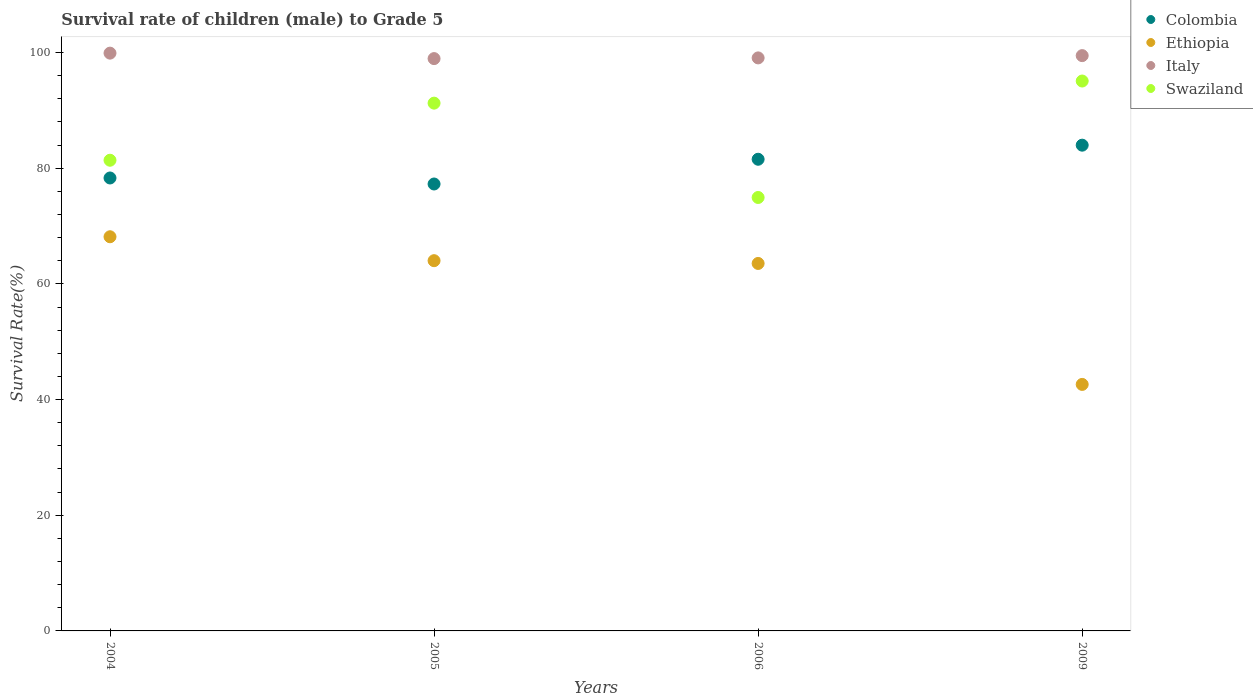What is the survival rate of male children to grade 5 in Swaziland in 2006?
Provide a short and direct response. 74.95. Across all years, what is the maximum survival rate of male children to grade 5 in Italy?
Offer a very short reply. 99.91. Across all years, what is the minimum survival rate of male children to grade 5 in Colombia?
Your response must be concise. 77.28. What is the total survival rate of male children to grade 5 in Italy in the graph?
Give a very brief answer. 397.43. What is the difference between the survival rate of male children to grade 5 in Ethiopia in 2004 and that in 2005?
Offer a very short reply. 4.14. What is the difference between the survival rate of male children to grade 5 in Swaziland in 2006 and the survival rate of male children to grade 5 in Italy in 2009?
Make the answer very short. -24.53. What is the average survival rate of male children to grade 5 in Ethiopia per year?
Your response must be concise. 59.59. In the year 2005, what is the difference between the survival rate of male children to grade 5 in Colombia and survival rate of male children to grade 5 in Swaziland?
Your answer should be compact. -13.98. What is the ratio of the survival rate of male children to grade 5 in Swaziland in 2004 to that in 2009?
Keep it short and to the point. 0.86. What is the difference between the highest and the second highest survival rate of male children to grade 5 in Swaziland?
Provide a succinct answer. 3.82. What is the difference between the highest and the lowest survival rate of male children to grade 5 in Colombia?
Provide a succinct answer. 6.71. Is the sum of the survival rate of male children to grade 5 in Swaziland in 2004 and 2005 greater than the maximum survival rate of male children to grade 5 in Colombia across all years?
Offer a terse response. Yes. How many dotlines are there?
Your answer should be very brief. 4. How many years are there in the graph?
Your response must be concise. 4. What is the difference between two consecutive major ticks on the Y-axis?
Your answer should be very brief. 20. Are the values on the major ticks of Y-axis written in scientific E-notation?
Provide a succinct answer. No. Does the graph contain any zero values?
Your answer should be compact. No. How many legend labels are there?
Offer a terse response. 4. What is the title of the graph?
Ensure brevity in your answer.  Survival rate of children (male) to Grade 5. What is the label or title of the Y-axis?
Offer a very short reply. Survival Rate(%). What is the Survival Rate(%) of Colombia in 2004?
Keep it short and to the point. 78.32. What is the Survival Rate(%) in Ethiopia in 2004?
Your answer should be compact. 68.16. What is the Survival Rate(%) in Italy in 2004?
Keep it short and to the point. 99.91. What is the Survival Rate(%) of Swaziland in 2004?
Your answer should be very brief. 81.39. What is the Survival Rate(%) of Colombia in 2005?
Give a very brief answer. 77.28. What is the Survival Rate(%) in Ethiopia in 2005?
Ensure brevity in your answer.  64.02. What is the Survival Rate(%) in Italy in 2005?
Offer a very short reply. 98.96. What is the Survival Rate(%) of Swaziland in 2005?
Make the answer very short. 91.26. What is the Survival Rate(%) of Colombia in 2006?
Provide a succinct answer. 81.56. What is the Survival Rate(%) in Ethiopia in 2006?
Provide a short and direct response. 63.54. What is the Survival Rate(%) in Italy in 2006?
Ensure brevity in your answer.  99.08. What is the Survival Rate(%) of Swaziland in 2006?
Keep it short and to the point. 74.95. What is the Survival Rate(%) in Colombia in 2009?
Your answer should be very brief. 83.99. What is the Survival Rate(%) in Ethiopia in 2009?
Your answer should be very brief. 42.62. What is the Survival Rate(%) of Italy in 2009?
Provide a short and direct response. 99.48. What is the Survival Rate(%) of Swaziland in 2009?
Provide a succinct answer. 95.08. Across all years, what is the maximum Survival Rate(%) in Colombia?
Provide a short and direct response. 83.99. Across all years, what is the maximum Survival Rate(%) of Ethiopia?
Provide a short and direct response. 68.16. Across all years, what is the maximum Survival Rate(%) of Italy?
Ensure brevity in your answer.  99.91. Across all years, what is the maximum Survival Rate(%) of Swaziland?
Offer a very short reply. 95.08. Across all years, what is the minimum Survival Rate(%) of Colombia?
Give a very brief answer. 77.28. Across all years, what is the minimum Survival Rate(%) of Ethiopia?
Offer a very short reply. 42.62. Across all years, what is the minimum Survival Rate(%) of Italy?
Your answer should be compact. 98.96. Across all years, what is the minimum Survival Rate(%) in Swaziland?
Your answer should be compact. 74.95. What is the total Survival Rate(%) of Colombia in the graph?
Offer a terse response. 321.15. What is the total Survival Rate(%) of Ethiopia in the graph?
Offer a terse response. 238.34. What is the total Survival Rate(%) of Italy in the graph?
Give a very brief answer. 397.43. What is the total Survival Rate(%) of Swaziland in the graph?
Ensure brevity in your answer.  342.68. What is the difference between the Survival Rate(%) in Colombia in 2004 and that in 2005?
Provide a short and direct response. 1.04. What is the difference between the Survival Rate(%) of Ethiopia in 2004 and that in 2005?
Offer a terse response. 4.14. What is the difference between the Survival Rate(%) of Italy in 2004 and that in 2005?
Your response must be concise. 0.94. What is the difference between the Survival Rate(%) of Swaziland in 2004 and that in 2005?
Provide a short and direct response. -9.87. What is the difference between the Survival Rate(%) in Colombia in 2004 and that in 2006?
Provide a succinct answer. -3.24. What is the difference between the Survival Rate(%) of Ethiopia in 2004 and that in 2006?
Provide a short and direct response. 4.62. What is the difference between the Survival Rate(%) in Italy in 2004 and that in 2006?
Your answer should be compact. 0.82. What is the difference between the Survival Rate(%) in Swaziland in 2004 and that in 2006?
Ensure brevity in your answer.  6.44. What is the difference between the Survival Rate(%) in Colombia in 2004 and that in 2009?
Provide a short and direct response. -5.67. What is the difference between the Survival Rate(%) in Ethiopia in 2004 and that in 2009?
Offer a terse response. 25.53. What is the difference between the Survival Rate(%) of Italy in 2004 and that in 2009?
Give a very brief answer. 0.43. What is the difference between the Survival Rate(%) of Swaziland in 2004 and that in 2009?
Provide a short and direct response. -13.7. What is the difference between the Survival Rate(%) of Colombia in 2005 and that in 2006?
Your answer should be compact. -4.28. What is the difference between the Survival Rate(%) in Ethiopia in 2005 and that in 2006?
Provide a short and direct response. 0.48. What is the difference between the Survival Rate(%) of Italy in 2005 and that in 2006?
Your response must be concise. -0.12. What is the difference between the Survival Rate(%) of Swaziland in 2005 and that in 2006?
Your response must be concise. 16.31. What is the difference between the Survival Rate(%) in Colombia in 2005 and that in 2009?
Ensure brevity in your answer.  -6.71. What is the difference between the Survival Rate(%) in Ethiopia in 2005 and that in 2009?
Ensure brevity in your answer.  21.4. What is the difference between the Survival Rate(%) of Italy in 2005 and that in 2009?
Your answer should be very brief. -0.51. What is the difference between the Survival Rate(%) in Swaziland in 2005 and that in 2009?
Your answer should be compact. -3.82. What is the difference between the Survival Rate(%) in Colombia in 2006 and that in 2009?
Your answer should be compact. -2.44. What is the difference between the Survival Rate(%) of Ethiopia in 2006 and that in 2009?
Make the answer very short. 20.92. What is the difference between the Survival Rate(%) in Italy in 2006 and that in 2009?
Give a very brief answer. -0.39. What is the difference between the Survival Rate(%) in Swaziland in 2006 and that in 2009?
Offer a very short reply. -20.14. What is the difference between the Survival Rate(%) of Colombia in 2004 and the Survival Rate(%) of Ethiopia in 2005?
Your response must be concise. 14.3. What is the difference between the Survival Rate(%) in Colombia in 2004 and the Survival Rate(%) in Italy in 2005?
Offer a very short reply. -20.64. What is the difference between the Survival Rate(%) of Colombia in 2004 and the Survival Rate(%) of Swaziland in 2005?
Make the answer very short. -12.94. What is the difference between the Survival Rate(%) in Ethiopia in 2004 and the Survival Rate(%) in Italy in 2005?
Offer a terse response. -30.81. What is the difference between the Survival Rate(%) in Ethiopia in 2004 and the Survival Rate(%) in Swaziland in 2005?
Offer a very short reply. -23.1. What is the difference between the Survival Rate(%) in Italy in 2004 and the Survival Rate(%) in Swaziland in 2005?
Your answer should be compact. 8.65. What is the difference between the Survival Rate(%) of Colombia in 2004 and the Survival Rate(%) of Ethiopia in 2006?
Make the answer very short. 14.78. What is the difference between the Survival Rate(%) of Colombia in 2004 and the Survival Rate(%) of Italy in 2006?
Offer a very short reply. -20.76. What is the difference between the Survival Rate(%) in Colombia in 2004 and the Survival Rate(%) in Swaziland in 2006?
Make the answer very short. 3.37. What is the difference between the Survival Rate(%) in Ethiopia in 2004 and the Survival Rate(%) in Italy in 2006?
Offer a very short reply. -30.93. What is the difference between the Survival Rate(%) of Ethiopia in 2004 and the Survival Rate(%) of Swaziland in 2006?
Make the answer very short. -6.79. What is the difference between the Survival Rate(%) of Italy in 2004 and the Survival Rate(%) of Swaziland in 2006?
Your response must be concise. 24.96. What is the difference between the Survival Rate(%) of Colombia in 2004 and the Survival Rate(%) of Ethiopia in 2009?
Your response must be concise. 35.7. What is the difference between the Survival Rate(%) of Colombia in 2004 and the Survival Rate(%) of Italy in 2009?
Ensure brevity in your answer.  -21.16. What is the difference between the Survival Rate(%) of Colombia in 2004 and the Survival Rate(%) of Swaziland in 2009?
Provide a short and direct response. -16.77. What is the difference between the Survival Rate(%) of Ethiopia in 2004 and the Survival Rate(%) of Italy in 2009?
Offer a very short reply. -31.32. What is the difference between the Survival Rate(%) of Ethiopia in 2004 and the Survival Rate(%) of Swaziland in 2009?
Provide a succinct answer. -26.93. What is the difference between the Survival Rate(%) of Italy in 2004 and the Survival Rate(%) of Swaziland in 2009?
Provide a short and direct response. 4.82. What is the difference between the Survival Rate(%) of Colombia in 2005 and the Survival Rate(%) of Ethiopia in 2006?
Provide a short and direct response. 13.74. What is the difference between the Survival Rate(%) of Colombia in 2005 and the Survival Rate(%) of Italy in 2006?
Make the answer very short. -21.8. What is the difference between the Survival Rate(%) in Colombia in 2005 and the Survival Rate(%) in Swaziland in 2006?
Offer a very short reply. 2.33. What is the difference between the Survival Rate(%) of Ethiopia in 2005 and the Survival Rate(%) of Italy in 2006?
Provide a succinct answer. -35.06. What is the difference between the Survival Rate(%) of Ethiopia in 2005 and the Survival Rate(%) of Swaziland in 2006?
Provide a succinct answer. -10.93. What is the difference between the Survival Rate(%) of Italy in 2005 and the Survival Rate(%) of Swaziland in 2006?
Ensure brevity in your answer.  24.01. What is the difference between the Survival Rate(%) in Colombia in 2005 and the Survival Rate(%) in Ethiopia in 2009?
Provide a succinct answer. 34.66. What is the difference between the Survival Rate(%) of Colombia in 2005 and the Survival Rate(%) of Italy in 2009?
Your answer should be compact. -22.2. What is the difference between the Survival Rate(%) of Colombia in 2005 and the Survival Rate(%) of Swaziland in 2009?
Provide a succinct answer. -17.8. What is the difference between the Survival Rate(%) in Ethiopia in 2005 and the Survival Rate(%) in Italy in 2009?
Ensure brevity in your answer.  -35.46. What is the difference between the Survival Rate(%) in Ethiopia in 2005 and the Survival Rate(%) in Swaziland in 2009?
Ensure brevity in your answer.  -31.06. What is the difference between the Survival Rate(%) of Italy in 2005 and the Survival Rate(%) of Swaziland in 2009?
Offer a very short reply. 3.88. What is the difference between the Survival Rate(%) of Colombia in 2006 and the Survival Rate(%) of Ethiopia in 2009?
Make the answer very short. 38.93. What is the difference between the Survival Rate(%) in Colombia in 2006 and the Survival Rate(%) in Italy in 2009?
Give a very brief answer. -17.92. What is the difference between the Survival Rate(%) in Colombia in 2006 and the Survival Rate(%) in Swaziland in 2009?
Your response must be concise. -13.53. What is the difference between the Survival Rate(%) in Ethiopia in 2006 and the Survival Rate(%) in Italy in 2009?
Ensure brevity in your answer.  -35.94. What is the difference between the Survival Rate(%) in Ethiopia in 2006 and the Survival Rate(%) in Swaziland in 2009?
Your answer should be compact. -31.54. What is the difference between the Survival Rate(%) of Italy in 2006 and the Survival Rate(%) of Swaziland in 2009?
Your answer should be very brief. 4. What is the average Survival Rate(%) in Colombia per year?
Ensure brevity in your answer.  80.29. What is the average Survival Rate(%) in Ethiopia per year?
Your answer should be compact. 59.59. What is the average Survival Rate(%) of Italy per year?
Your answer should be compact. 99.36. What is the average Survival Rate(%) of Swaziland per year?
Your answer should be compact. 85.67. In the year 2004, what is the difference between the Survival Rate(%) of Colombia and Survival Rate(%) of Ethiopia?
Ensure brevity in your answer.  10.16. In the year 2004, what is the difference between the Survival Rate(%) in Colombia and Survival Rate(%) in Italy?
Provide a short and direct response. -21.59. In the year 2004, what is the difference between the Survival Rate(%) of Colombia and Survival Rate(%) of Swaziland?
Provide a succinct answer. -3.07. In the year 2004, what is the difference between the Survival Rate(%) in Ethiopia and Survival Rate(%) in Italy?
Keep it short and to the point. -31.75. In the year 2004, what is the difference between the Survival Rate(%) of Ethiopia and Survival Rate(%) of Swaziland?
Provide a short and direct response. -13.23. In the year 2004, what is the difference between the Survival Rate(%) in Italy and Survival Rate(%) in Swaziland?
Provide a succinct answer. 18.52. In the year 2005, what is the difference between the Survival Rate(%) in Colombia and Survival Rate(%) in Ethiopia?
Provide a short and direct response. 13.26. In the year 2005, what is the difference between the Survival Rate(%) in Colombia and Survival Rate(%) in Italy?
Make the answer very short. -21.68. In the year 2005, what is the difference between the Survival Rate(%) in Colombia and Survival Rate(%) in Swaziland?
Your answer should be compact. -13.98. In the year 2005, what is the difference between the Survival Rate(%) in Ethiopia and Survival Rate(%) in Italy?
Keep it short and to the point. -34.94. In the year 2005, what is the difference between the Survival Rate(%) in Ethiopia and Survival Rate(%) in Swaziland?
Offer a terse response. -27.24. In the year 2005, what is the difference between the Survival Rate(%) in Italy and Survival Rate(%) in Swaziland?
Your answer should be very brief. 7.7. In the year 2006, what is the difference between the Survival Rate(%) in Colombia and Survival Rate(%) in Ethiopia?
Provide a succinct answer. 18.02. In the year 2006, what is the difference between the Survival Rate(%) in Colombia and Survival Rate(%) in Italy?
Your response must be concise. -17.53. In the year 2006, what is the difference between the Survival Rate(%) of Colombia and Survival Rate(%) of Swaziland?
Keep it short and to the point. 6.61. In the year 2006, what is the difference between the Survival Rate(%) of Ethiopia and Survival Rate(%) of Italy?
Keep it short and to the point. -35.54. In the year 2006, what is the difference between the Survival Rate(%) in Ethiopia and Survival Rate(%) in Swaziland?
Provide a short and direct response. -11.41. In the year 2006, what is the difference between the Survival Rate(%) of Italy and Survival Rate(%) of Swaziland?
Provide a short and direct response. 24.14. In the year 2009, what is the difference between the Survival Rate(%) in Colombia and Survival Rate(%) in Ethiopia?
Offer a terse response. 41.37. In the year 2009, what is the difference between the Survival Rate(%) of Colombia and Survival Rate(%) of Italy?
Provide a short and direct response. -15.48. In the year 2009, what is the difference between the Survival Rate(%) of Colombia and Survival Rate(%) of Swaziland?
Provide a short and direct response. -11.09. In the year 2009, what is the difference between the Survival Rate(%) of Ethiopia and Survival Rate(%) of Italy?
Ensure brevity in your answer.  -56.85. In the year 2009, what is the difference between the Survival Rate(%) of Ethiopia and Survival Rate(%) of Swaziland?
Give a very brief answer. -52.46. In the year 2009, what is the difference between the Survival Rate(%) in Italy and Survival Rate(%) in Swaziland?
Provide a short and direct response. 4.39. What is the ratio of the Survival Rate(%) in Colombia in 2004 to that in 2005?
Ensure brevity in your answer.  1.01. What is the ratio of the Survival Rate(%) in Ethiopia in 2004 to that in 2005?
Give a very brief answer. 1.06. What is the ratio of the Survival Rate(%) in Italy in 2004 to that in 2005?
Provide a succinct answer. 1.01. What is the ratio of the Survival Rate(%) in Swaziland in 2004 to that in 2005?
Offer a very short reply. 0.89. What is the ratio of the Survival Rate(%) of Colombia in 2004 to that in 2006?
Your answer should be compact. 0.96. What is the ratio of the Survival Rate(%) of Ethiopia in 2004 to that in 2006?
Ensure brevity in your answer.  1.07. What is the ratio of the Survival Rate(%) of Italy in 2004 to that in 2006?
Your answer should be compact. 1.01. What is the ratio of the Survival Rate(%) in Swaziland in 2004 to that in 2006?
Keep it short and to the point. 1.09. What is the ratio of the Survival Rate(%) of Colombia in 2004 to that in 2009?
Your answer should be very brief. 0.93. What is the ratio of the Survival Rate(%) of Ethiopia in 2004 to that in 2009?
Give a very brief answer. 1.6. What is the ratio of the Survival Rate(%) in Italy in 2004 to that in 2009?
Provide a short and direct response. 1. What is the ratio of the Survival Rate(%) in Swaziland in 2004 to that in 2009?
Give a very brief answer. 0.86. What is the ratio of the Survival Rate(%) of Colombia in 2005 to that in 2006?
Offer a terse response. 0.95. What is the ratio of the Survival Rate(%) of Ethiopia in 2005 to that in 2006?
Offer a terse response. 1.01. What is the ratio of the Survival Rate(%) in Italy in 2005 to that in 2006?
Provide a succinct answer. 1. What is the ratio of the Survival Rate(%) of Swaziland in 2005 to that in 2006?
Keep it short and to the point. 1.22. What is the ratio of the Survival Rate(%) of Colombia in 2005 to that in 2009?
Offer a very short reply. 0.92. What is the ratio of the Survival Rate(%) in Ethiopia in 2005 to that in 2009?
Provide a short and direct response. 1.5. What is the ratio of the Survival Rate(%) in Swaziland in 2005 to that in 2009?
Your response must be concise. 0.96. What is the ratio of the Survival Rate(%) of Ethiopia in 2006 to that in 2009?
Offer a very short reply. 1.49. What is the ratio of the Survival Rate(%) of Swaziland in 2006 to that in 2009?
Give a very brief answer. 0.79. What is the difference between the highest and the second highest Survival Rate(%) of Colombia?
Offer a terse response. 2.44. What is the difference between the highest and the second highest Survival Rate(%) of Ethiopia?
Provide a succinct answer. 4.14. What is the difference between the highest and the second highest Survival Rate(%) of Italy?
Your answer should be very brief. 0.43. What is the difference between the highest and the second highest Survival Rate(%) in Swaziland?
Make the answer very short. 3.82. What is the difference between the highest and the lowest Survival Rate(%) in Colombia?
Provide a succinct answer. 6.71. What is the difference between the highest and the lowest Survival Rate(%) of Ethiopia?
Give a very brief answer. 25.53. What is the difference between the highest and the lowest Survival Rate(%) of Italy?
Offer a terse response. 0.94. What is the difference between the highest and the lowest Survival Rate(%) in Swaziland?
Give a very brief answer. 20.14. 